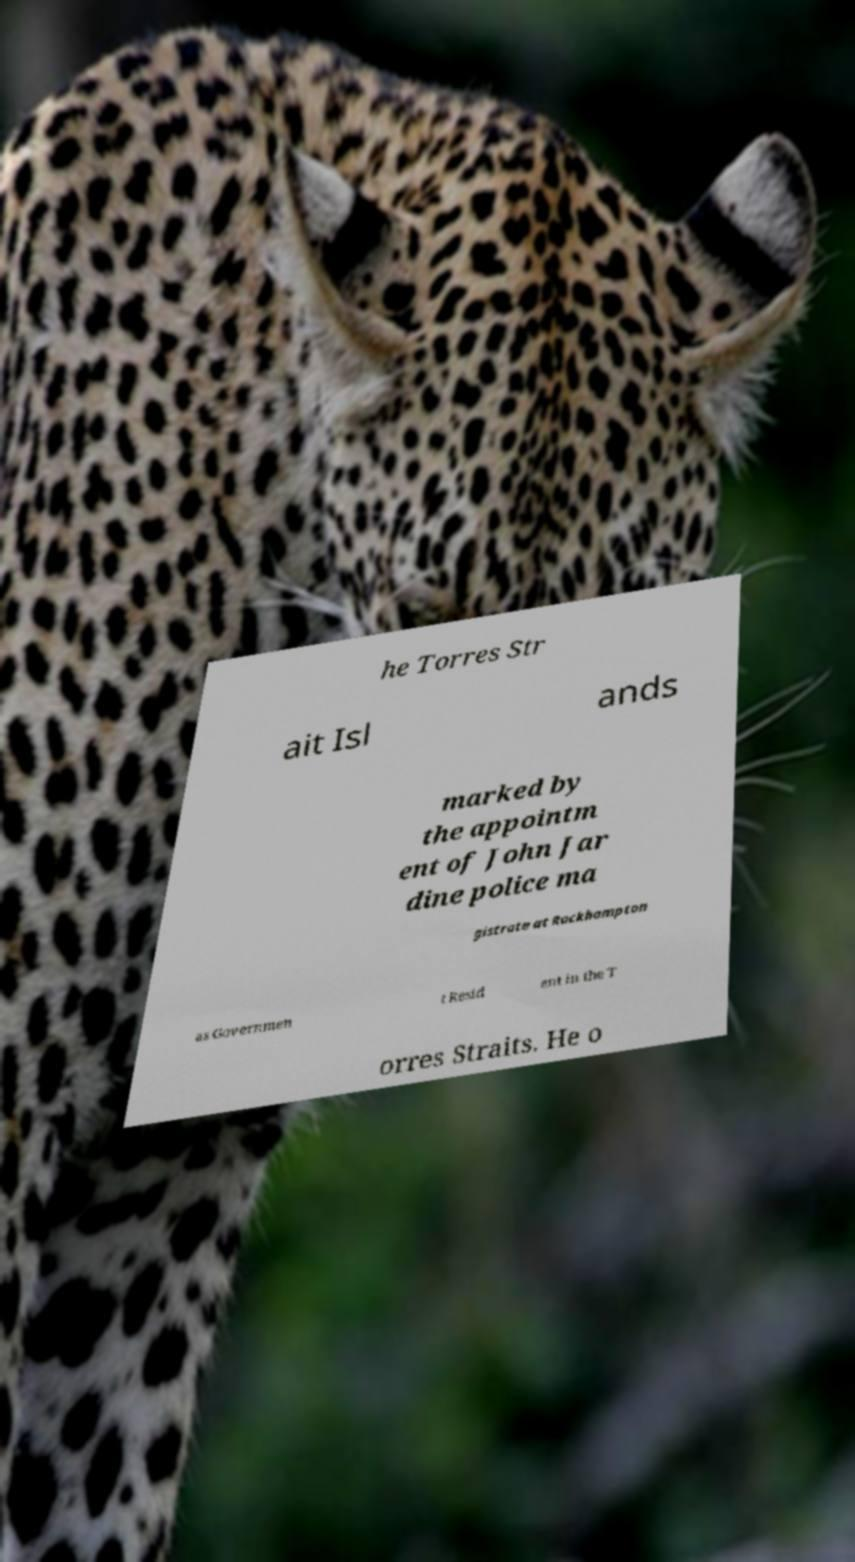What messages or text are displayed in this image? I need them in a readable, typed format. he Torres Str ait Isl ands marked by the appointm ent of John Jar dine police ma gistrate at Rockhampton as Governmen t Resid ent in the T orres Straits. He o 